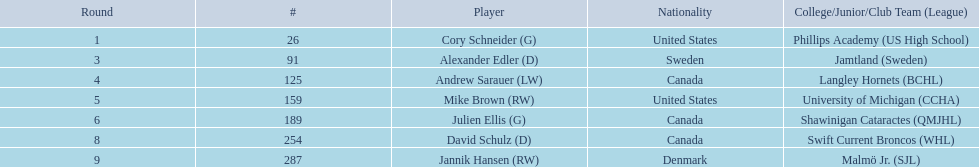Which players have canadian nationality? Andrew Sarauer (LW), Julien Ellis (G), David Schulz (D). Of those, which attended langley hornets? Andrew Sarauer (LW). 